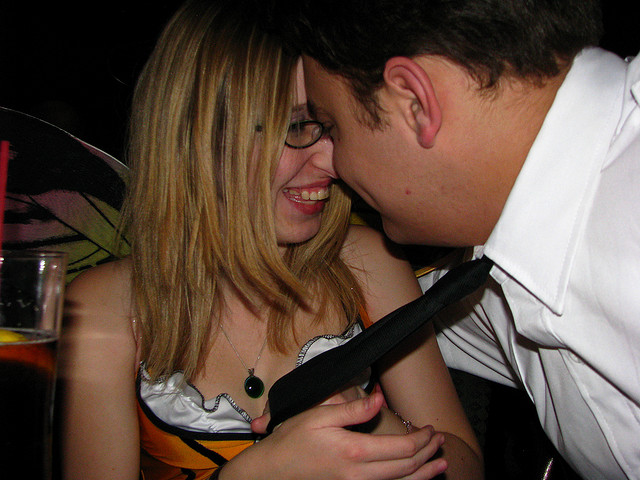<image>What color is the wristband? It is ambiguous what color the wristband is. It could be black, white, or silver. What type of food are they sharing? There is no food being shared in the image. What is the hand moving toward? It is unknown what the hand is moving toward. It could be moving toward the tie, chest, or face. What print is this woman's dress? It's unclear what print this woman's dress is. It could be striped or plaid. What color is the wristband? I don't know what color is the wristband. It can be black, white, silver or none at all. What type of food are they sharing? I am not sure what type of food they are sharing. It can be seen nothing, cake, wine, or Italian food. What is the hand moving toward? I don't know what the hand is moving toward. It can be toward the tie, chest, or face. What print is this woman's dress? It is not clear what print is on the woman's dress. It can be either striped or plaid. 